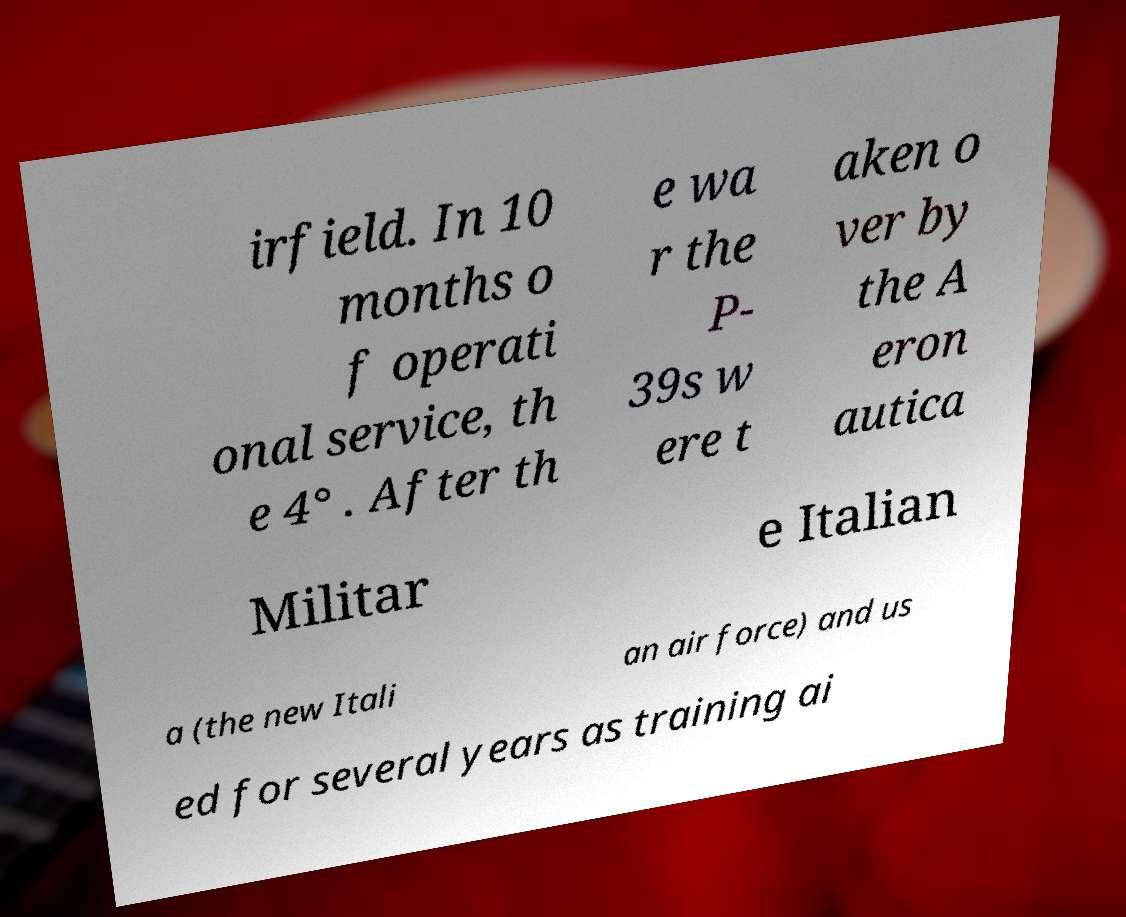There's text embedded in this image that I need extracted. Can you transcribe it verbatim? irfield. In 10 months o f operati onal service, th e 4° . After th e wa r the P- 39s w ere t aken o ver by the A eron autica Militar e Italian a (the new Itali an air force) and us ed for several years as training ai 